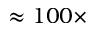Convert formula to latex. <formula><loc_0><loc_0><loc_500><loc_500>\approx 1 0 0 \times</formula> 